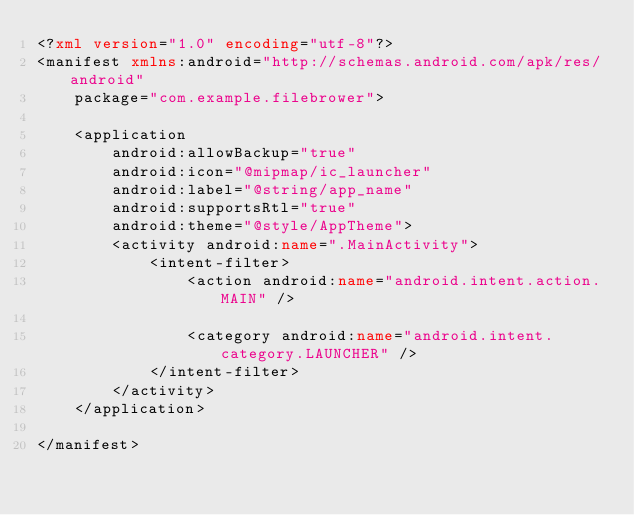Convert code to text. <code><loc_0><loc_0><loc_500><loc_500><_XML_><?xml version="1.0" encoding="utf-8"?>
<manifest xmlns:android="http://schemas.android.com/apk/res/android"
    package="com.example.filebrower">

    <application
        android:allowBackup="true"
        android:icon="@mipmap/ic_launcher"
        android:label="@string/app_name"
        android:supportsRtl="true"
        android:theme="@style/AppTheme">
        <activity android:name=".MainActivity">
            <intent-filter>
                <action android:name="android.intent.action.MAIN" />

                <category android:name="android.intent.category.LAUNCHER" />
            </intent-filter>
        </activity>
    </application>

</manifest>
</code> 